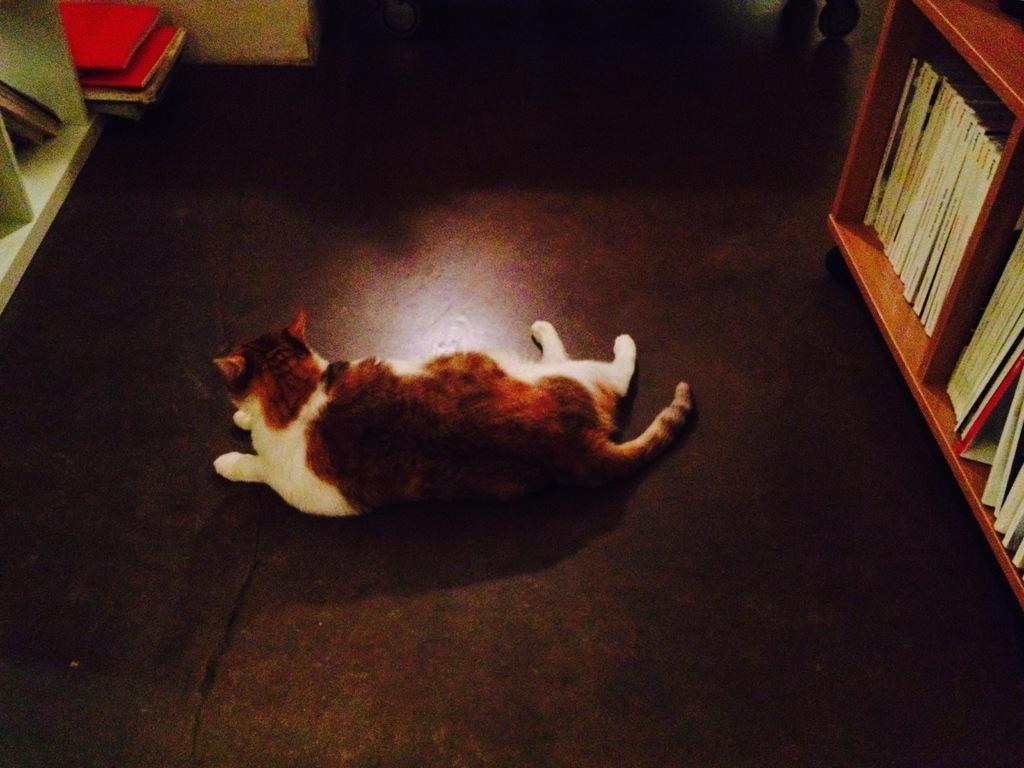How would you summarize this image in a sentence or two? In this image, we can see a cat is laying on the floor. On the right side and left side of the image, we can see few books are placed on the racks. 